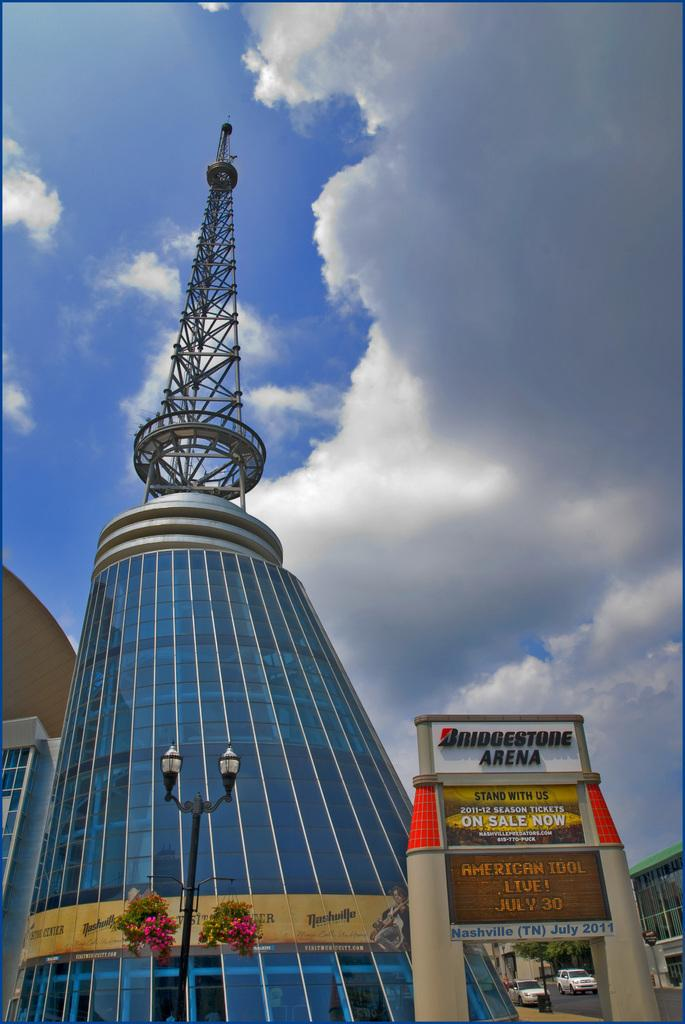What type of structures can be seen in the image? There are buildings in the image. What decorative elements are present in the image? There are banners in the image. What type of plants can be seen in the image? There are flowers in the image. What type of lighting is present in the image? There are street lamps in the image. What type of animals can be seen in the image? There are cats in the image. What is visible at the top of the image? The sky is visible at the top of the image. What can be seen in the sky? Clouds are present in the sky. What type of pie is being served to the geese in the image? There are no geese or pies present in the image. Can you describe the smile on the cat's face in the image? There are no smiles depicted on the cats in the image. 